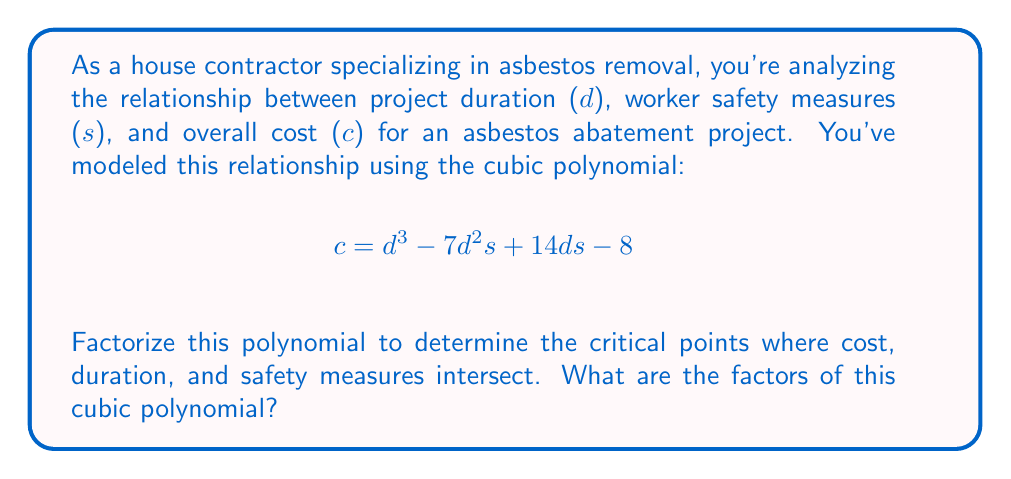Solve this math problem. To factorize this cubic polynomial, we'll follow these steps:

1) First, let's identify the polynomial:
   $$c = d^3 - 7d^2s + 14ds - 8$$

2) We can factor out the greatest common factor (GCF) if there is one. In this case, there isn't a common factor for all terms.

3) Next, we'll check if this is a perfect cube. The general form of a perfect cube is $a^3 + 3a^2b + 3ab^2 + b^3$. Our polynomial doesn't match this pattern.

4) We'll use the rational root theorem to find possible factors. The possible rational roots are the factors of the constant term (8): ±1, ±2, ±4, ±8.

5) Let's test these values:
   For d = 1: $1^3 - 7(1)^2s + 14(1)s - 8 = 1 - 7s + 14s - 8 = 7s - 7 = 7(s-1)$
   We've found a factor: $(d-1)$

6) Now we can divide the original polynomial by $(d-1)$:
   $$\frac{d^3 - 7d^2s + 14ds - 8}{d-1} = d^2 + (1-7s)d + (14s-8)$$

7) The quadratic factor $d^2 + (1-7s)d + (14s-8)$ can be further factored:
   $$d^2 + (1-7s)d + (14s-8) = (d+2s-4)(d-7s+5)$$

8) Therefore, the complete factorization is:
   $$c = (d-1)(d+2s-4)(d-7s+5)$$
Answer: The factors of the cubic polynomial are: $(d-1)$, $(d+2s-4)$, and $(d-7s+5)$. 